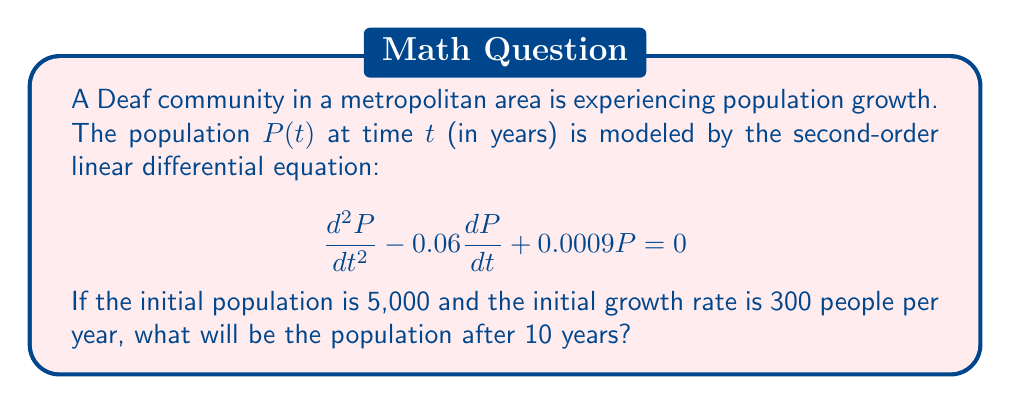Teach me how to tackle this problem. To solve this problem, we need to follow these steps:

1) The general solution for this second-order linear differential equation is:

   $$P(t) = C_1e^{r_1t} + C_2e^{r_2t}$$

   where $r_1$ and $r_2$ are the roots of the characteristic equation.

2) The characteristic equation is:
   
   $$r^2 - 0.06r + 0.0009 = 0$$

3) Solving this quadratic equation:
   
   $$r = \frac{0.06 \pm \sqrt{0.06^2 - 4(0.0009)}}{2} = \frac{0.06 \pm \sqrt{0.0036 - 0.0036}}{2} = 0.03$$

4) Since there's only one root, the general solution becomes:

   $$P(t) = (C_1 + C_2t)e^{0.03t}$$

5) Now we use the initial conditions:
   
   $P(0) = 5000$ and $P'(0) = 300$

6) From $P(0) = 5000$:
   
   $$5000 = C_1$$

7) From $P'(t) = (C_2 + 0.03C_1 + 0.03C_2t)e^{0.03t}$, we get $P'(0) = 300$:
   
   $$300 = C_2 + 0.03(5000) = C_2 + 150$$
   $$C_2 = 150$$

8) Therefore, the particular solution is:

   $$P(t) = (5000 + 150t)e^{0.03t}$$

9) To find the population after 10 years, we calculate $P(10)$:

   $$P(10) = (5000 + 150(10))e^{0.03(10)} = 6500e^{0.3} \approx 8,937$$
Answer: The population after 10 years will be approximately 8,937 people. 